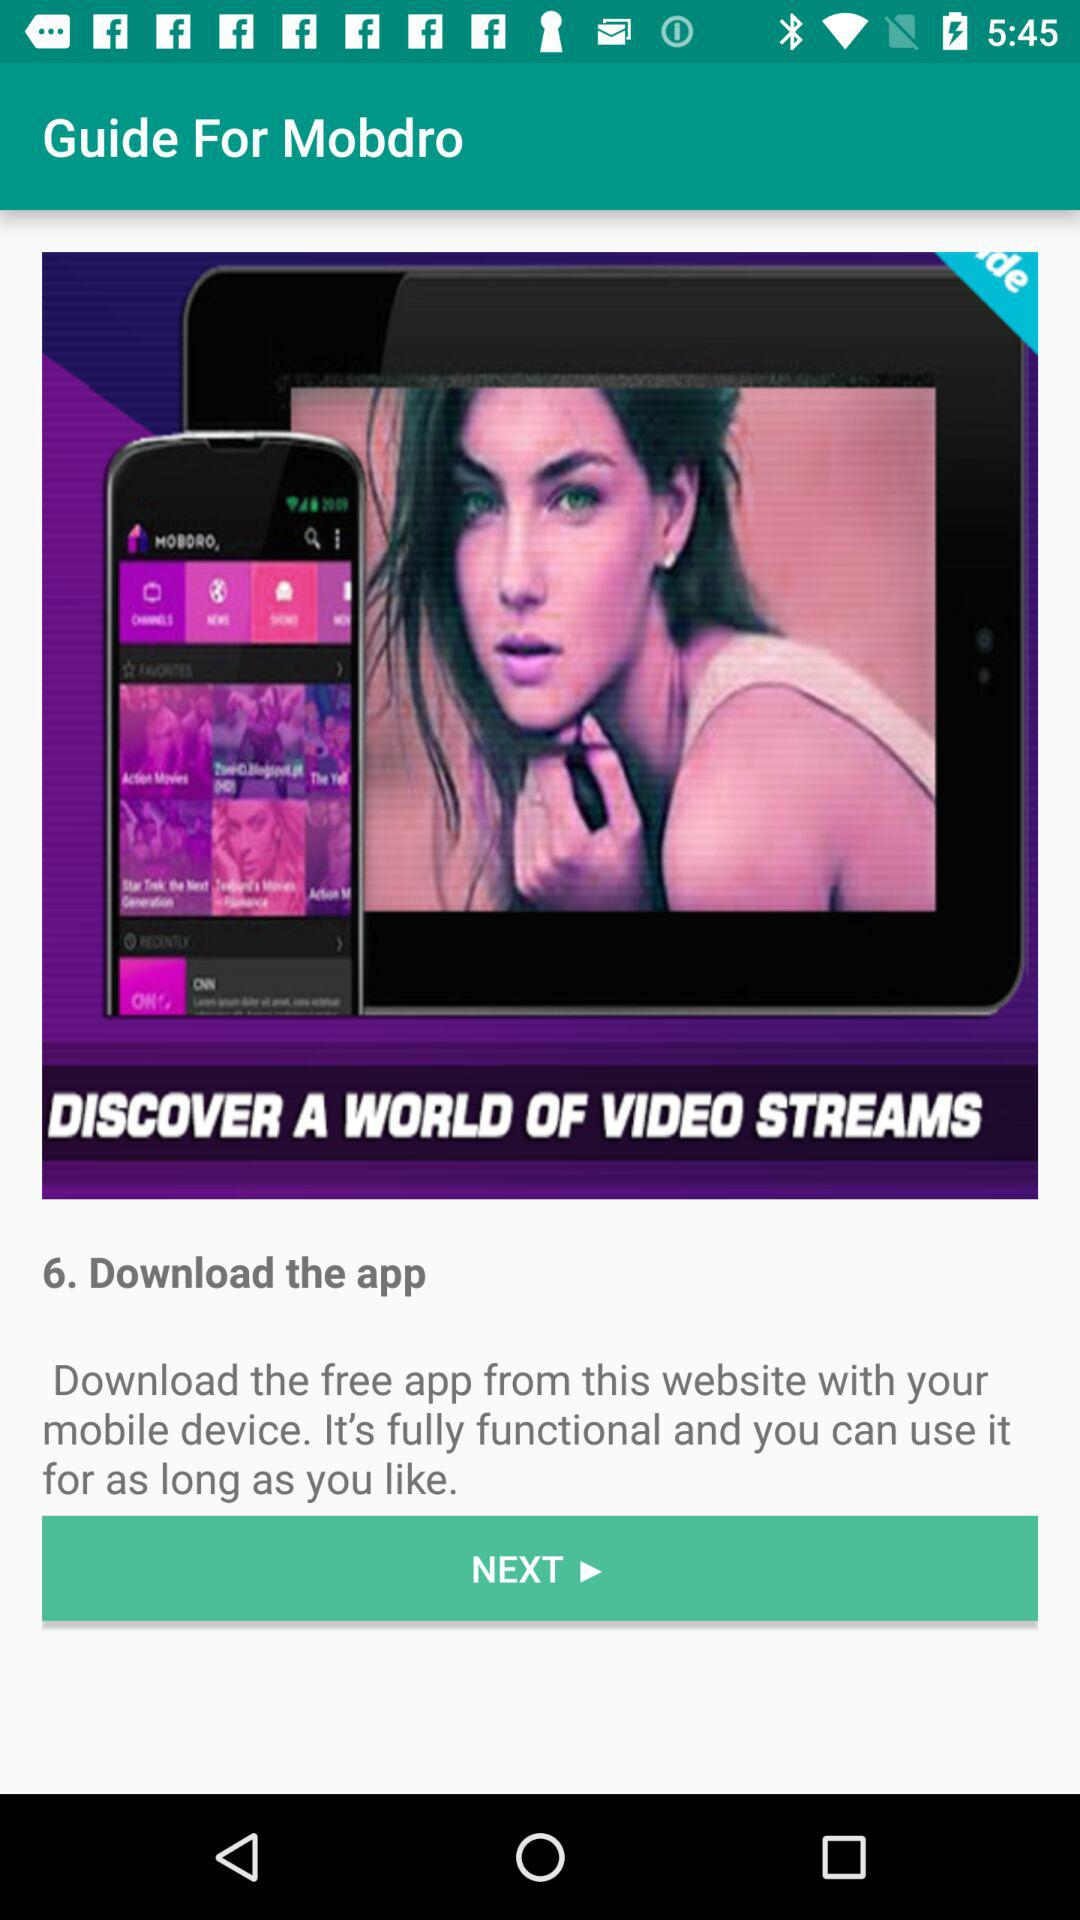What is the application name? The application name is "Guide For Mobdro". 